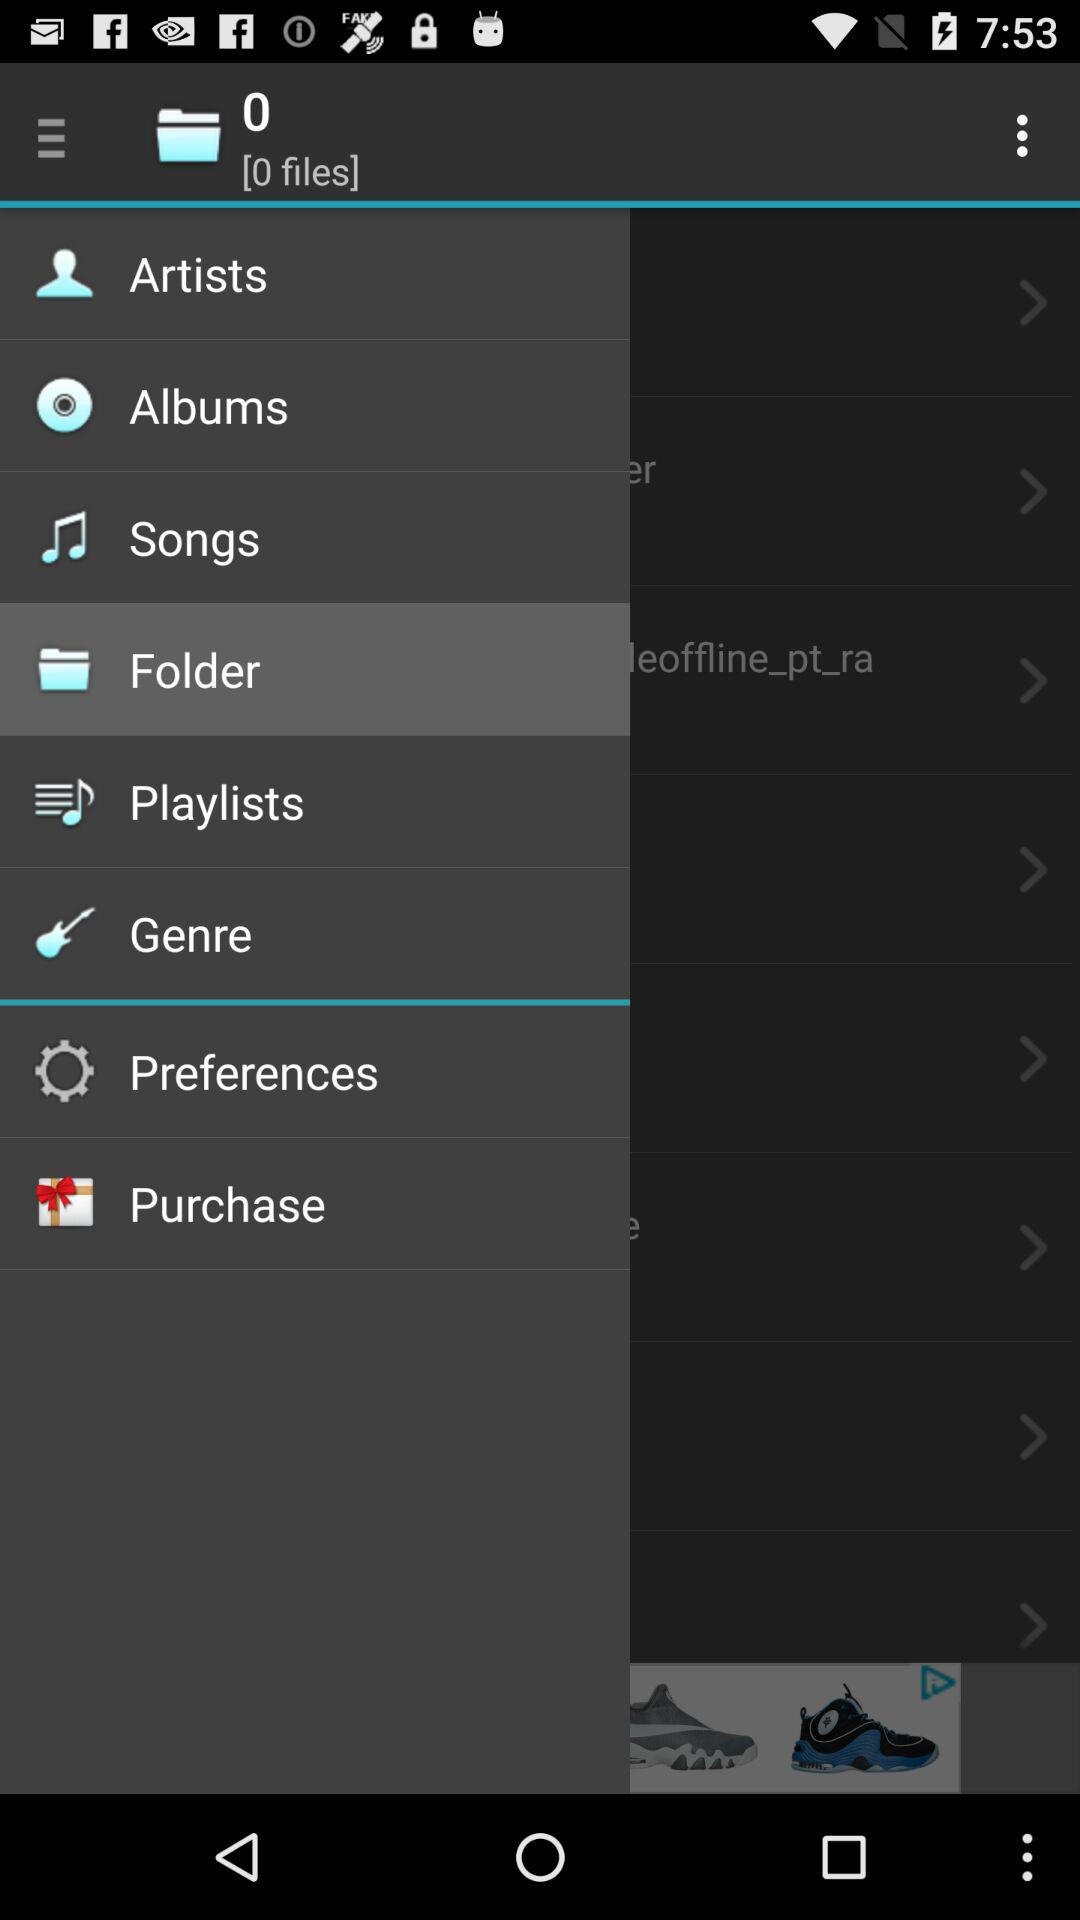Which item has been selected? The selected item is "Folder". 